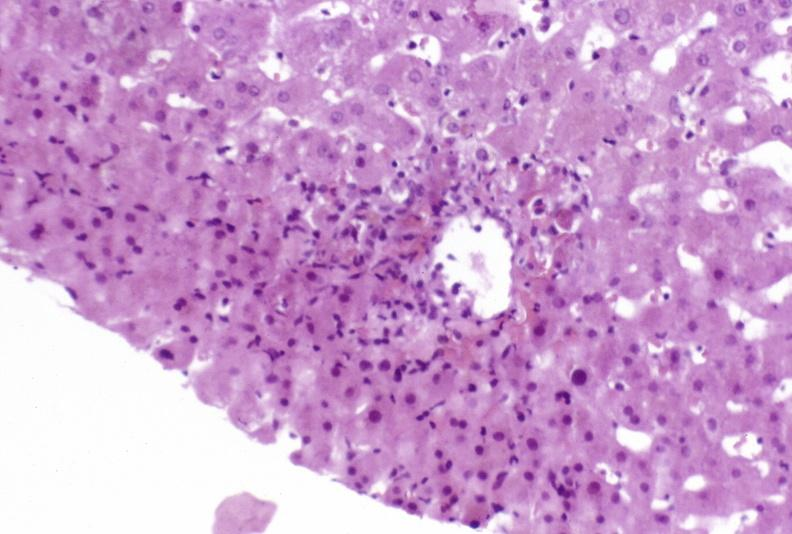s liver present?
Answer the question using a single word or phrase. Yes 